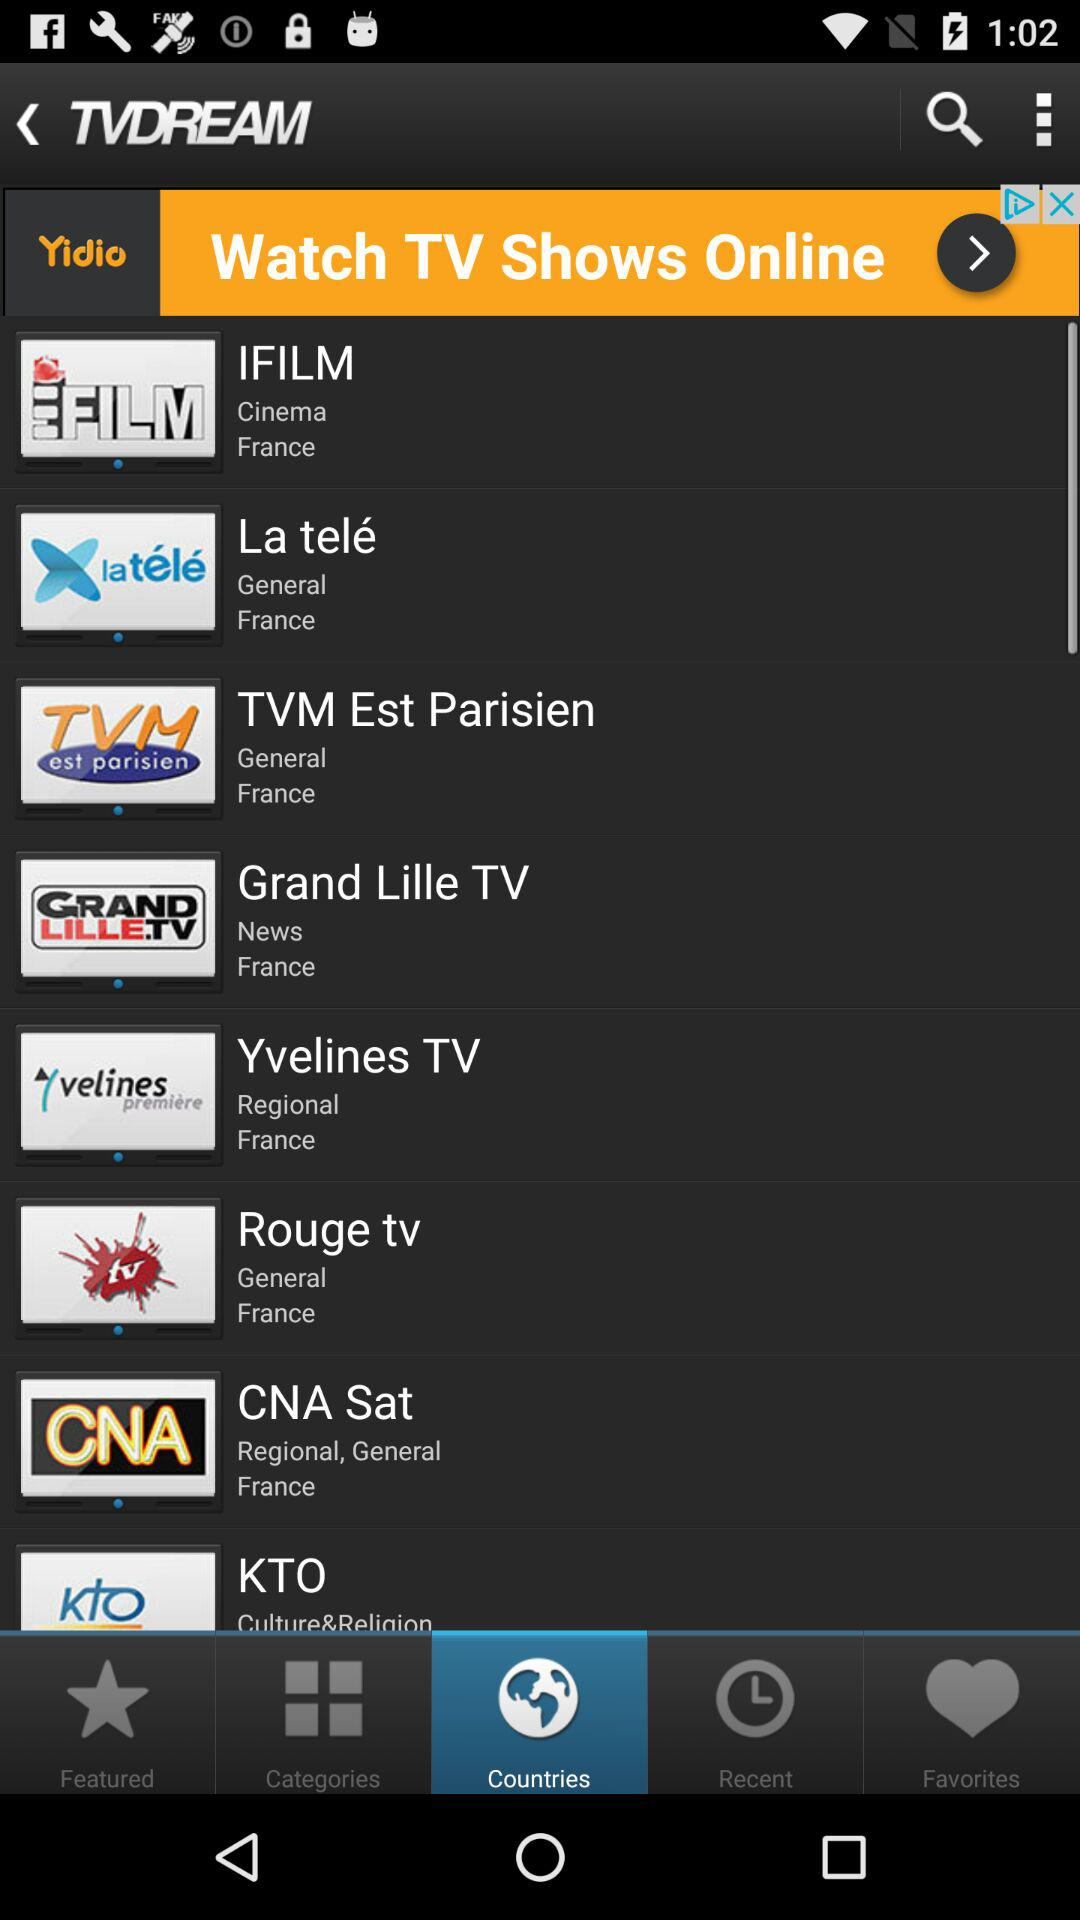What are the regional channel names? The regional channel names are "Yvelines TV" and "CNA Sat". 